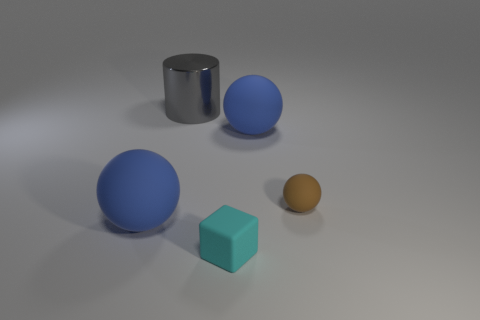How many balls have the same color as the shiny cylinder?
Provide a short and direct response. 0. There is a large blue object left of the gray object that is behind the big blue sphere on the left side of the cube; what is it made of?
Provide a succinct answer. Rubber. The large rubber sphere that is behind the sphere on the left side of the cyan object is what color?
Your response must be concise. Blue. How many tiny things are cylinders or blue matte objects?
Your answer should be very brief. 0. How many big cylinders have the same material as the brown thing?
Provide a succinct answer. 0. What is the size of the thing left of the big metal thing?
Keep it short and to the point. Large. The tiny object in front of the big sphere in front of the brown thing is what shape?
Make the answer very short. Cube. There is a tiny cyan cube that is on the left side of the large matte object that is behind the tiny brown rubber thing; how many things are to the right of it?
Provide a short and direct response. 2. Is the number of cyan blocks that are in front of the cylinder less than the number of small gray rubber balls?
Give a very brief answer. No. Is there anything else that has the same shape as the cyan object?
Provide a succinct answer. No. 